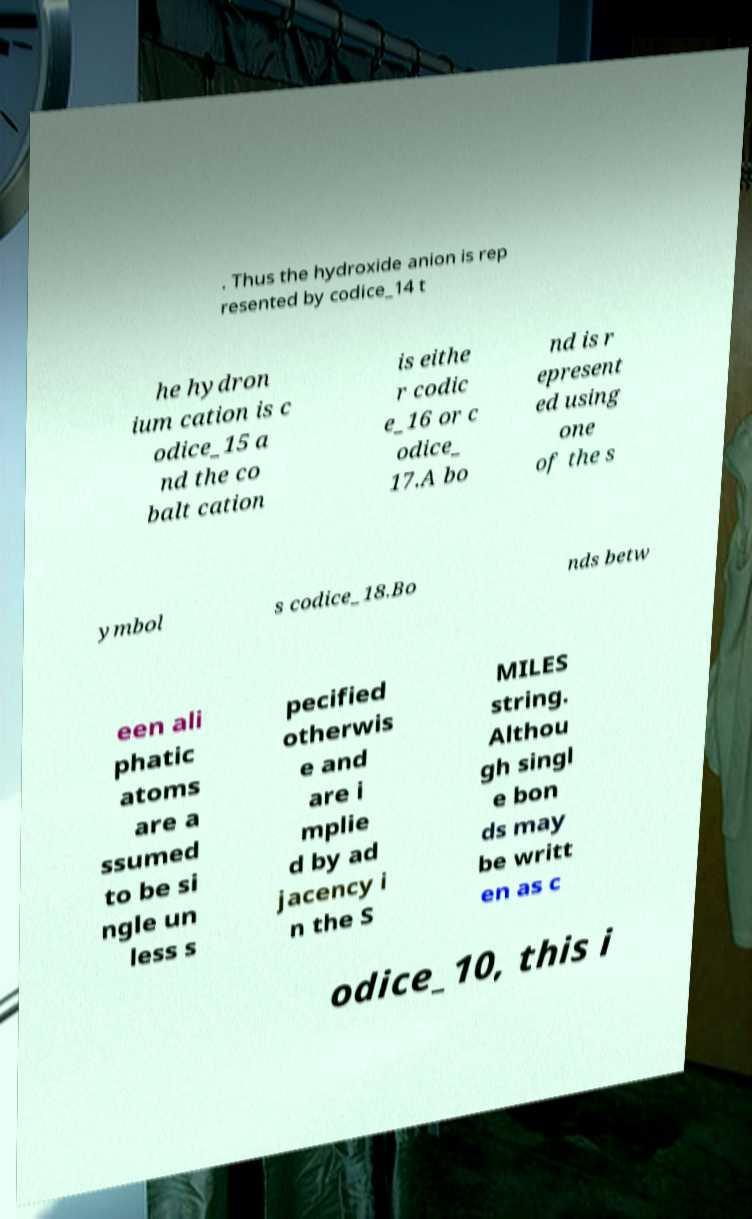I need the written content from this picture converted into text. Can you do that? . Thus the hydroxide anion is rep resented by codice_14 t he hydron ium cation is c odice_15 a nd the co balt cation is eithe r codic e_16 or c odice_ 17.A bo nd is r epresent ed using one of the s ymbol s codice_18.Bo nds betw een ali phatic atoms are a ssumed to be si ngle un less s pecified otherwis e and are i mplie d by ad jacency i n the S MILES string. Althou gh singl e bon ds may be writt en as c odice_10, this i 